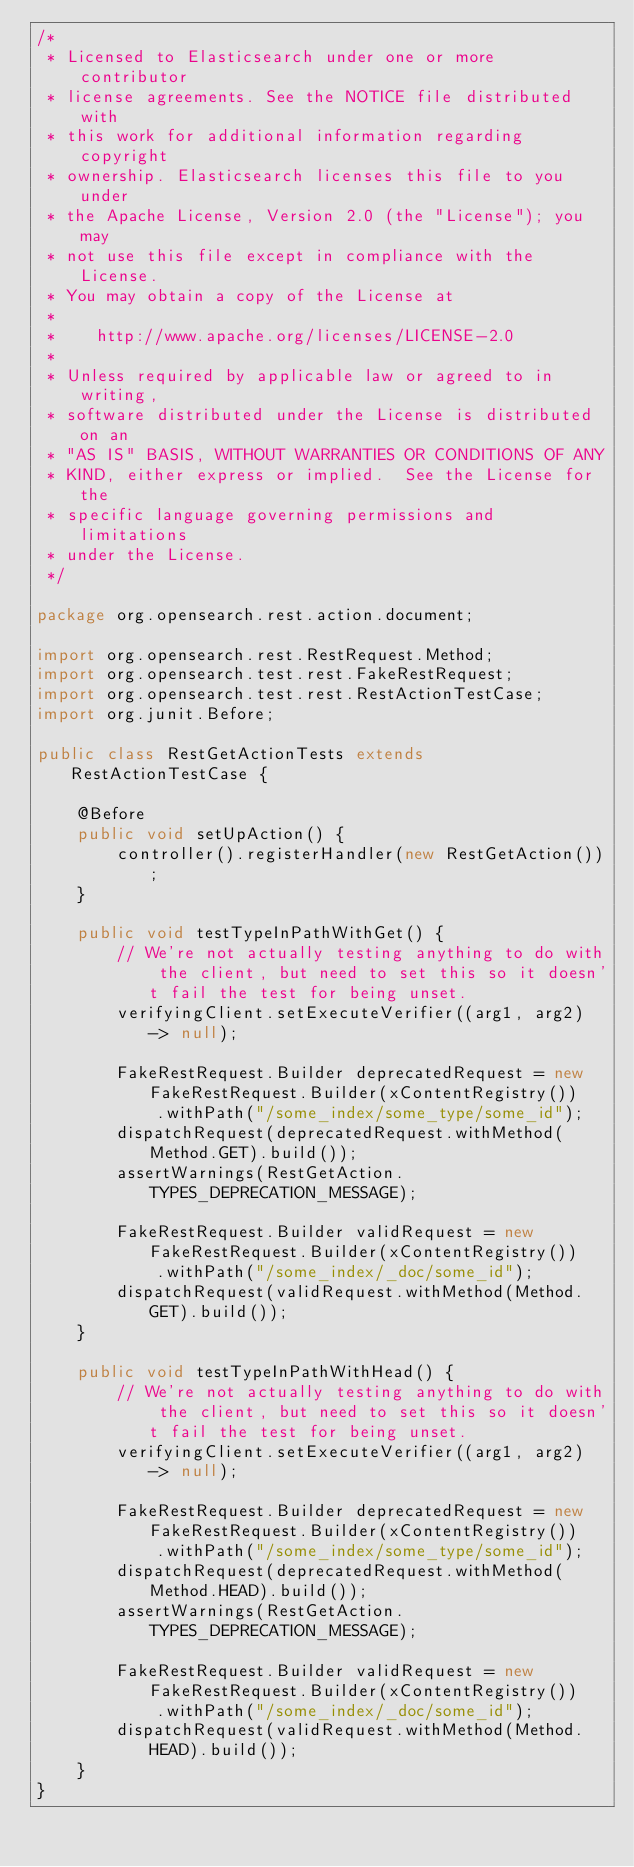<code> <loc_0><loc_0><loc_500><loc_500><_Java_>/*
 * Licensed to Elasticsearch under one or more contributor
 * license agreements. See the NOTICE file distributed with
 * this work for additional information regarding copyright
 * ownership. Elasticsearch licenses this file to you under
 * the Apache License, Version 2.0 (the "License"); you may
 * not use this file except in compliance with the License.
 * You may obtain a copy of the License at
 *
 *    http://www.apache.org/licenses/LICENSE-2.0
 *
 * Unless required by applicable law or agreed to in writing,
 * software distributed under the License is distributed on an
 * "AS IS" BASIS, WITHOUT WARRANTIES OR CONDITIONS OF ANY
 * KIND, either express or implied.  See the License for the
 * specific language governing permissions and limitations
 * under the License.
 */

package org.opensearch.rest.action.document;

import org.opensearch.rest.RestRequest.Method;
import org.opensearch.test.rest.FakeRestRequest;
import org.opensearch.test.rest.RestActionTestCase;
import org.junit.Before;

public class RestGetActionTests extends RestActionTestCase {

    @Before
    public void setUpAction() {
        controller().registerHandler(new RestGetAction());
    }

    public void testTypeInPathWithGet() {
        // We're not actually testing anything to do with the client, but need to set this so it doesn't fail the test for being unset.
        verifyingClient.setExecuteVerifier((arg1, arg2) -> null);

        FakeRestRequest.Builder deprecatedRequest = new FakeRestRequest.Builder(xContentRegistry())
            .withPath("/some_index/some_type/some_id");
        dispatchRequest(deprecatedRequest.withMethod(Method.GET).build());
        assertWarnings(RestGetAction.TYPES_DEPRECATION_MESSAGE);

        FakeRestRequest.Builder validRequest = new FakeRestRequest.Builder(xContentRegistry())
            .withPath("/some_index/_doc/some_id");
        dispatchRequest(validRequest.withMethod(Method.GET).build());
    }

    public void testTypeInPathWithHead() {
        // We're not actually testing anything to do with the client, but need to set this so it doesn't fail the test for being unset.
        verifyingClient.setExecuteVerifier((arg1, arg2) -> null);

        FakeRestRequest.Builder deprecatedRequest = new FakeRestRequest.Builder(xContentRegistry())
            .withPath("/some_index/some_type/some_id");
        dispatchRequest(deprecatedRequest.withMethod(Method.HEAD).build());
        assertWarnings(RestGetAction.TYPES_DEPRECATION_MESSAGE);

        FakeRestRequest.Builder validRequest = new FakeRestRequest.Builder(xContentRegistry())
            .withPath("/some_index/_doc/some_id");
        dispatchRequest(validRequest.withMethod(Method.HEAD).build());
    }
}
</code> 